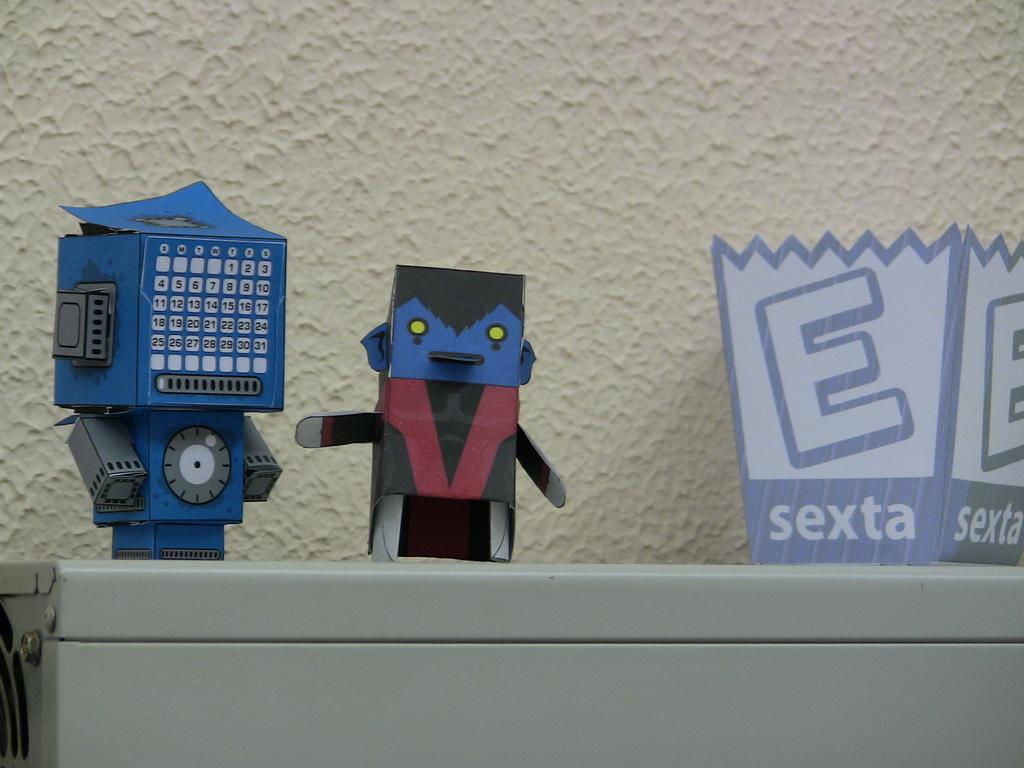What is the main object in the image? There is a grey colored metal object in the image. What is placed on the metal object? There are toys made up of cardboard on the metal object. What color is the wall in the background? The background features a cream-colored wall. Are there any baits visible on the metal object in the image? No, there are no baits present in the image. Can you see any tooth on the metal object or the toys in the image? No, there are no teeth visible in the image. 